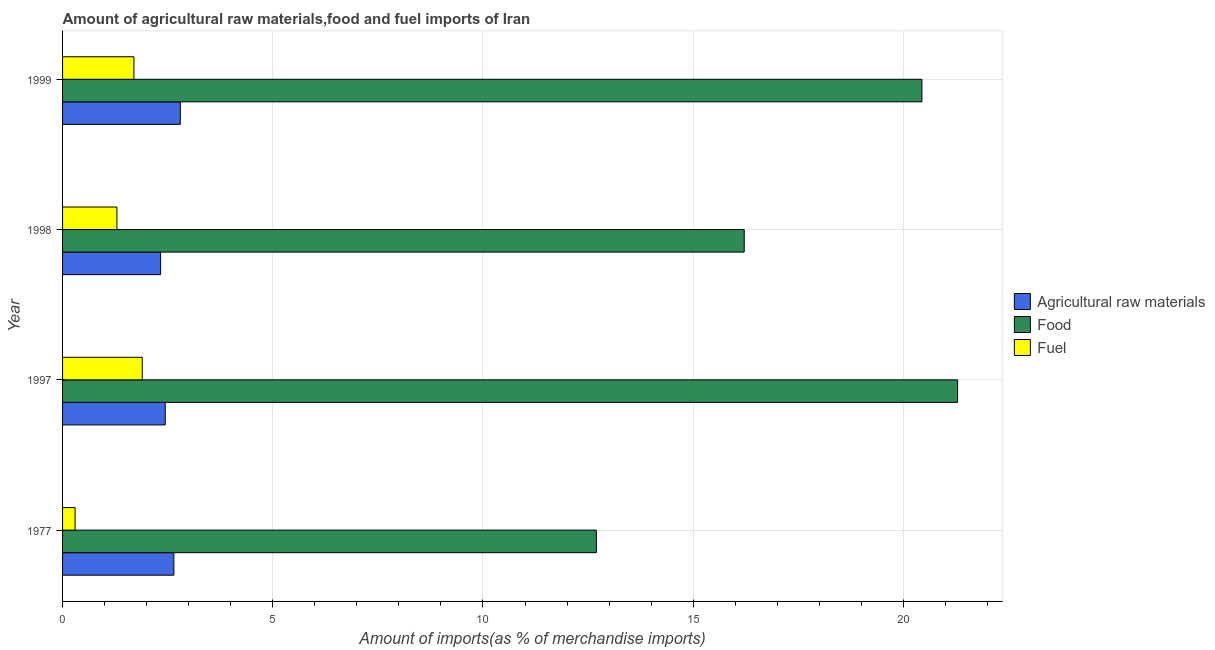How many groups of bars are there?
Ensure brevity in your answer.  4. Are the number of bars on each tick of the Y-axis equal?
Give a very brief answer. Yes. How many bars are there on the 1st tick from the bottom?
Give a very brief answer. 3. What is the percentage of raw materials imports in 1977?
Offer a terse response. 2.65. Across all years, what is the maximum percentage of raw materials imports?
Your response must be concise. 2.8. Across all years, what is the minimum percentage of raw materials imports?
Make the answer very short. 2.33. In which year was the percentage of food imports maximum?
Give a very brief answer. 1997. What is the total percentage of food imports in the graph?
Ensure brevity in your answer.  70.64. What is the difference between the percentage of raw materials imports in 1977 and that in 1997?
Keep it short and to the point. 0.2. What is the difference between the percentage of food imports in 1997 and the percentage of raw materials imports in 1999?
Offer a very short reply. 18.49. What is the average percentage of raw materials imports per year?
Provide a short and direct response. 2.56. In the year 1998, what is the difference between the percentage of food imports and percentage of raw materials imports?
Ensure brevity in your answer.  13.88. What is the ratio of the percentage of raw materials imports in 1977 to that in 1999?
Keep it short and to the point. 0.94. What is the difference between the highest and the second highest percentage of raw materials imports?
Your answer should be compact. 0.15. What is the difference between the highest and the lowest percentage of food imports?
Your response must be concise. 8.59. What does the 1st bar from the top in 1977 represents?
Keep it short and to the point. Fuel. What does the 3rd bar from the bottom in 1977 represents?
Give a very brief answer. Fuel. What is the difference between two consecutive major ticks on the X-axis?
Your answer should be very brief. 5. How many legend labels are there?
Your answer should be compact. 3. How are the legend labels stacked?
Your answer should be very brief. Vertical. What is the title of the graph?
Ensure brevity in your answer.  Amount of agricultural raw materials,food and fuel imports of Iran. What is the label or title of the X-axis?
Make the answer very short. Amount of imports(as % of merchandise imports). What is the Amount of imports(as % of merchandise imports) in Agricultural raw materials in 1977?
Your answer should be compact. 2.65. What is the Amount of imports(as % of merchandise imports) in Food in 1977?
Offer a terse response. 12.7. What is the Amount of imports(as % of merchandise imports) of Fuel in 1977?
Your answer should be compact. 0.3. What is the Amount of imports(as % of merchandise imports) of Agricultural raw materials in 1997?
Your response must be concise. 2.44. What is the Amount of imports(as % of merchandise imports) of Food in 1997?
Make the answer very short. 21.29. What is the Amount of imports(as % of merchandise imports) in Fuel in 1997?
Give a very brief answer. 1.9. What is the Amount of imports(as % of merchandise imports) in Agricultural raw materials in 1998?
Make the answer very short. 2.33. What is the Amount of imports(as % of merchandise imports) of Food in 1998?
Make the answer very short. 16.21. What is the Amount of imports(as % of merchandise imports) in Fuel in 1998?
Offer a very short reply. 1.29. What is the Amount of imports(as % of merchandise imports) of Agricultural raw materials in 1999?
Offer a very short reply. 2.8. What is the Amount of imports(as % of merchandise imports) of Food in 1999?
Keep it short and to the point. 20.44. What is the Amount of imports(as % of merchandise imports) in Fuel in 1999?
Provide a succinct answer. 1.7. Across all years, what is the maximum Amount of imports(as % of merchandise imports) in Agricultural raw materials?
Provide a short and direct response. 2.8. Across all years, what is the maximum Amount of imports(as % of merchandise imports) in Food?
Your answer should be compact. 21.29. Across all years, what is the maximum Amount of imports(as % of merchandise imports) in Fuel?
Your answer should be very brief. 1.9. Across all years, what is the minimum Amount of imports(as % of merchandise imports) in Agricultural raw materials?
Offer a terse response. 2.33. Across all years, what is the minimum Amount of imports(as % of merchandise imports) in Food?
Provide a succinct answer. 12.7. Across all years, what is the minimum Amount of imports(as % of merchandise imports) in Fuel?
Your answer should be compact. 0.3. What is the total Amount of imports(as % of merchandise imports) of Agricultural raw materials in the graph?
Make the answer very short. 10.22. What is the total Amount of imports(as % of merchandise imports) of Food in the graph?
Your answer should be very brief. 70.64. What is the total Amount of imports(as % of merchandise imports) of Fuel in the graph?
Your response must be concise. 5.18. What is the difference between the Amount of imports(as % of merchandise imports) in Agricultural raw materials in 1977 and that in 1997?
Make the answer very short. 0.2. What is the difference between the Amount of imports(as % of merchandise imports) of Food in 1977 and that in 1997?
Offer a very short reply. -8.59. What is the difference between the Amount of imports(as % of merchandise imports) in Fuel in 1977 and that in 1997?
Make the answer very short. -1.6. What is the difference between the Amount of imports(as % of merchandise imports) in Agricultural raw materials in 1977 and that in 1998?
Give a very brief answer. 0.32. What is the difference between the Amount of imports(as % of merchandise imports) in Food in 1977 and that in 1998?
Make the answer very short. -3.52. What is the difference between the Amount of imports(as % of merchandise imports) in Fuel in 1977 and that in 1998?
Your answer should be compact. -1. What is the difference between the Amount of imports(as % of merchandise imports) in Agricultural raw materials in 1977 and that in 1999?
Offer a very short reply. -0.15. What is the difference between the Amount of imports(as % of merchandise imports) of Food in 1977 and that in 1999?
Offer a terse response. -7.74. What is the difference between the Amount of imports(as % of merchandise imports) of Fuel in 1977 and that in 1999?
Make the answer very short. -1.4. What is the difference between the Amount of imports(as % of merchandise imports) of Agricultural raw materials in 1997 and that in 1998?
Offer a terse response. 0.11. What is the difference between the Amount of imports(as % of merchandise imports) in Food in 1997 and that in 1998?
Your answer should be very brief. 5.08. What is the difference between the Amount of imports(as % of merchandise imports) in Fuel in 1997 and that in 1998?
Provide a succinct answer. 0.6. What is the difference between the Amount of imports(as % of merchandise imports) in Agricultural raw materials in 1997 and that in 1999?
Give a very brief answer. -0.36. What is the difference between the Amount of imports(as % of merchandise imports) of Food in 1997 and that in 1999?
Your response must be concise. 0.85. What is the difference between the Amount of imports(as % of merchandise imports) in Fuel in 1997 and that in 1999?
Make the answer very short. 0.2. What is the difference between the Amount of imports(as % of merchandise imports) in Agricultural raw materials in 1998 and that in 1999?
Provide a succinct answer. -0.47. What is the difference between the Amount of imports(as % of merchandise imports) in Food in 1998 and that in 1999?
Offer a very short reply. -4.23. What is the difference between the Amount of imports(as % of merchandise imports) in Fuel in 1998 and that in 1999?
Offer a terse response. -0.4. What is the difference between the Amount of imports(as % of merchandise imports) in Agricultural raw materials in 1977 and the Amount of imports(as % of merchandise imports) in Food in 1997?
Provide a succinct answer. -18.64. What is the difference between the Amount of imports(as % of merchandise imports) in Agricultural raw materials in 1977 and the Amount of imports(as % of merchandise imports) in Fuel in 1997?
Provide a short and direct response. 0.75. What is the difference between the Amount of imports(as % of merchandise imports) in Food in 1977 and the Amount of imports(as % of merchandise imports) in Fuel in 1997?
Keep it short and to the point. 10.8. What is the difference between the Amount of imports(as % of merchandise imports) of Agricultural raw materials in 1977 and the Amount of imports(as % of merchandise imports) of Food in 1998?
Make the answer very short. -13.57. What is the difference between the Amount of imports(as % of merchandise imports) of Agricultural raw materials in 1977 and the Amount of imports(as % of merchandise imports) of Fuel in 1998?
Offer a terse response. 1.35. What is the difference between the Amount of imports(as % of merchandise imports) in Food in 1977 and the Amount of imports(as % of merchandise imports) in Fuel in 1998?
Your response must be concise. 11.4. What is the difference between the Amount of imports(as % of merchandise imports) in Agricultural raw materials in 1977 and the Amount of imports(as % of merchandise imports) in Food in 1999?
Keep it short and to the point. -17.79. What is the difference between the Amount of imports(as % of merchandise imports) of Food in 1977 and the Amount of imports(as % of merchandise imports) of Fuel in 1999?
Your answer should be compact. 11. What is the difference between the Amount of imports(as % of merchandise imports) of Agricultural raw materials in 1997 and the Amount of imports(as % of merchandise imports) of Food in 1998?
Keep it short and to the point. -13.77. What is the difference between the Amount of imports(as % of merchandise imports) of Agricultural raw materials in 1997 and the Amount of imports(as % of merchandise imports) of Fuel in 1998?
Offer a very short reply. 1.15. What is the difference between the Amount of imports(as % of merchandise imports) of Food in 1997 and the Amount of imports(as % of merchandise imports) of Fuel in 1998?
Your answer should be compact. 20. What is the difference between the Amount of imports(as % of merchandise imports) in Agricultural raw materials in 1997 and the Amount of imports(as % of merchandise imports) in Food in 1999?
Your answer should be very brief. -18. What is the difference between the Amount of imports(as % of merchandise imports) of Agricultural raw materials in 1997 and the Amount of imports(as % of merchandise imports) of Fuel in 1999?
Offer a terse response. 0.75. What is the difference between the Amount of imports(as % of merchandise imports) in Food in 1997 and the Amount of imports(as % of merchandise imports) in Fuel in 1999?
Give a very brief answer. 19.59. What is the difference between the Amount of imports(as % of merchandise imports) of Agricultural raw materials in 1998 and the Amount of imports(as % of merchandise imports) of Food in 1999?
Make the answer very short. -18.11. What is the difference between the Amount of imports(as % of merchandise imports) in Agricultural raw materials in 1998 and the Amount of imports(as % of merchandise imports) in Fuel in 1999?
Your response must be concise. 0.64. What is the difference between the Amount of imports(as % of merchandise imports) in Food in 1998 and the Amount of imports(as % of merchandise imports) in Fuel in 1999?
Ensure brevity in your answer.  14.52. What is the average Amount of imports(as % of merchandise imports) in Agricultural raw materials per year?
Your response must be concise. 2.56. What is the average Amount of imports(as % of merchandise imports) of Food per year?
Keep it short and to the point. 17.66. What is the average Amount of imports(as % of merchandise imports) in Fuel per year?
Provide a short and direct response. 1.3. In the year 1977, what is the difference between the Amount of imports(as % of merchandise imports) of Agricultural raw materials and Amount of imports(as % of merchandise imports) of Food?
Offer a terse response. -10.05. In the year 1977, what is the difference between the Amount of imports(as % of merchandise imports) of Agricultural raw materials and Amount of imports(as % of merchandise imports) of Fuel?
Your answer should be compact. 2.35. In the year 1977, what is the difference between the Amount of imports(as % of merchandise imports) of Food and Amount of imports(as % of merchandise imports) of Fuel?
Give a very brief answer. 12.4. In the year 1997, what is the difference between the Amount of imports(as % of merchandise imports) of Agricultural raw materials and Amount of imports(as % of merchandise imports) of Food?
Offer a very short reply. -18.85. In the year 1997, what is the difference between the Amount of imports(as % of merchandise imports) of Agricultural raw materials and Amount of imports(as % of merchandise imports) of Fuel?
Ensure brevity in your answer.  0.55. In the year 1997, what is the difference between the Amount of imports(as % of merchandise imports) in Food and Amount of imports(as % of merchandise imports) in Fuel?
Provide a succinct answer. 19.39. In the year 1998, what is the difference between the Amount of imports(as % of merchandise imports) in Agricultural raw materials and Amount of imports(as % of merchandise imports) in Food?
Your response must be concise. -13.88. In the year 1998, what is the difference between the Amount of imports(as % of merchandise imports) of Agricultural raw materials and Amount of imports(as % of merchandise imports) of Fuel?
Offer a very short reply. 1.04. In the year 1998, what is the difference between the Amount of imports(as % of merchandise imports) of Food and Amount of imports(as % of merchandise imports) of Fuel?
Ensure brevity in your answer.  14.92. In the year 1999, what is the difference between the Amount of imports(as % of merchandise imports) in Agricultural raw materials and Amount of imports(as % of merchandise imports) in Food?
Offer a very short reply. -17.64. In the year 1999, what is the difference between the Amount of imports(as % of merchandise imports) in Agricultural raw materials and Amount of imports(as % of merchandise imports) in Fuel?
Offer a terse response. 1.1. In the year 1999, what is the difference between the Amount of imports(as % of merchandise imports) of Food and Amount of imports(as % of merchandise imports) of Fuel?
Provide a succinct answer. 18.74. What is the ratio of the Amount of imports(as % of merchandise imports) of Agricultural raw materials in 1977 to that in 1997?
Provide a short and direct response. 1.08. What is the ratio of the Amount of imports(as % of merchandise imports) of Food in 1977 to that in 1997?
Make the answer very short. 0.6. What is the ratio of the Amount of imports(as % of merchandise imports) in Fuel in 1977 to that in 1997?
Your response must be concise. 0.16. What is the ratio of the Amount of imports(as % of merchandise imports) of Agricultural raw materials in 1977 to that in 1998?
Ensure brevity in your answer.  1.14. What is the ratio of the Amount of imports(as % of merchandise imports) of Food in 1977 to that in 1998?
Your answer should be compact. 0.78. What is the ratio of the Amount of imports(as % of merchandise imports) of Fuel in 1977 to that in 1998?
Offer a terse response. 0.23. What is the ratio of the Amount of imports(as % of merchandise imports) of Agricultural raw materials in 1977 to that in 1999?
Your answer should be compact. 0.95. What is the ratio of the Amount of imports(as % of merchandise imports) in Food in 1977 to that in 1999?
Give a very brief answer. 0.62. What is the ratio of the Amount of imports(as % of merchandise imports) in Fuel in 1977 to that in 1999?
Your answer should be very brief. 0.18. What is the ratio of the Amount of imports(as % of merchandise imports) of Agricultural raw materials in 1997 to that in 1998?
Your answer should be very brief. 1.05. What is the ratio of the Amount of imports(as % of merchandise imports) in Food in 1997 to that in 1998?
Make the answer very short. 1.31. What is the ratio of the Amount of imports(as % of merchandise imports) in Fuel in 1997 to that in 1998?
Offer a terse response. 1.47. What is the ratio of the Amount of imports(as % of merchandise imports) of Agricultural raw materials in 1997 to that in 1999?
Provide a succinct answer. 0.87. What is the ratio of the Amount of imports(as % of merchandise imports) of Food in 1997 to that in 1999?
Your answer should be compact. 1.04. What is the ratio of the Amount of imports(as % of merchandise imports) in Fuel in 1997 to that in 1999?
Make the answer very short. 1.12. What is the ratio of the Amount of imports(as % of merchandise imports) in Agricultural raw materials in 1998 to that in 1999?
Your response must be concise. 0.83. What is the ratio of the Amount of imports(as % of merchandise imports) in Food in 1998 to that in 1999?
Your answer should be very brief. 0.79. What is the ratio of the Amount of imports(as % of merchandise imports) in Fuel in 1998 to that in 1999?
Ensure brevity in your answer.  0.76. What is the difference between the highest and the second highest Amount of imports(as % of merchandise imports) of Agricultural raw materials?
Give a very brief answer. 0.15. What is the difference between the highest and the second highest Amount of imports(as % of merchandise imports) in Food?
Offer a very short reply. 0.85. What is the difference between the highest and the second highest Amount of imports(as % of merchandise imports) of Fuel?
Provide a short and direct response. 0.2. What is the difference between the highest and the lowest Amount of imports(as % of merchandise imports) of Agricultural raw materials?
Offer a terse response. 0.47. What is the difference between the highest and the lowest Amount of imports(as % of merchandise imports) in Food?
Make the answer very short. 8.59. What is the difference between the highest and the lowest Amount of imports(as % of merchandise imports) in Fuel?
Offer a terse response. 1.6. 